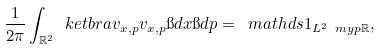Convert formula to latex. <formula><loc_0><loc_0><loc_500><loc_500>\frac { 1 } { 2 \pi } \int _ { \mathbb { R } ^ { 2 } } \ k e t b r a { v _ { x , p } } { v _ { x , p } } \i d x \i d p = \ m a t h d s { 1 } _ { L ^ { 2 } \ m y p { \mathbb { R } } } ,</formula> 